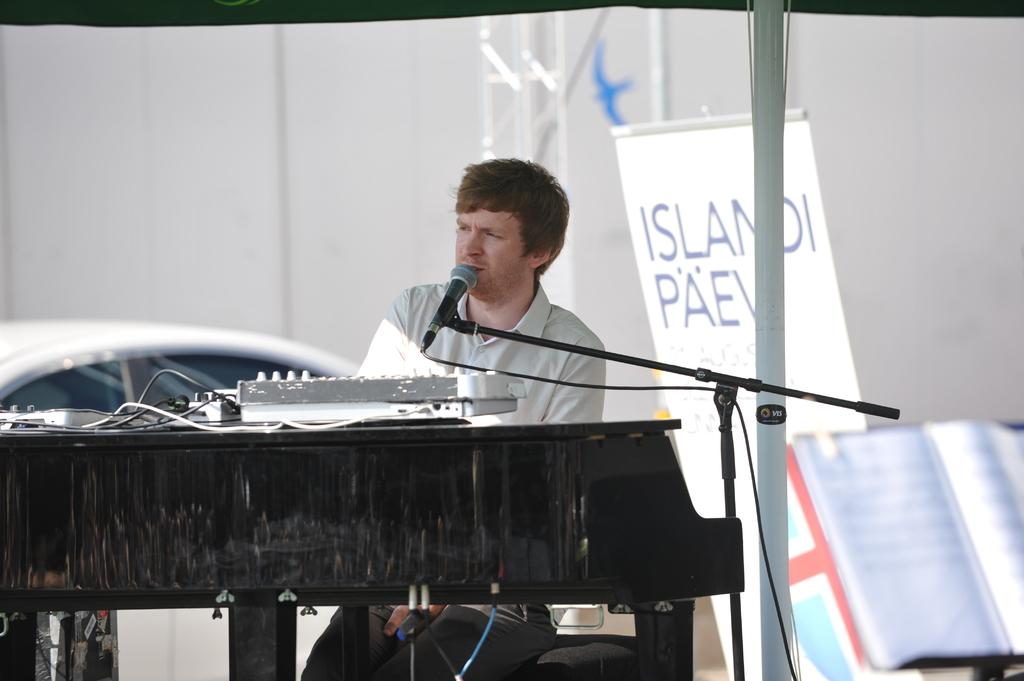What is the person in the image doing? The person is playing a keyboard. What object is in front of the person? There is a microphone in front of the person. What can be seen behind the person? There are books and a white-colored banner behind the person. Where is the sink located in the image? There is no sink present in the image. What type of crate is being used by the person in the image? There is no crate present in the image. 